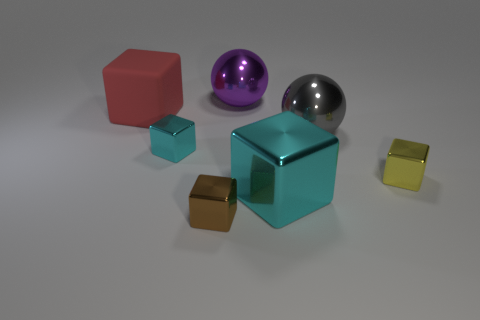Subtract all tiny metallic cubes. How many cubes are left? 2 Subtract all yellow cubes. How many cubes are left? 4 Subtract all green balls. Subtract all purple cubes. How many balls are left? 2 Subtract all cyan cubes. How many brown balls are left? 0 Subtract all rubber objects. Subtract all tiny cyan objects. How many objects are left? 5 Add 3 tiny brown shiny blocks. How many tiny brown shiny blocks are left? 4 Add 5 small cubes. How many small cubes exist? 8 Add 2 small brown things. How many objects exist? 9 Subtract 0 purple blocks. How many objects are left? 7 Subtract all balls. How many objects are left? 5 